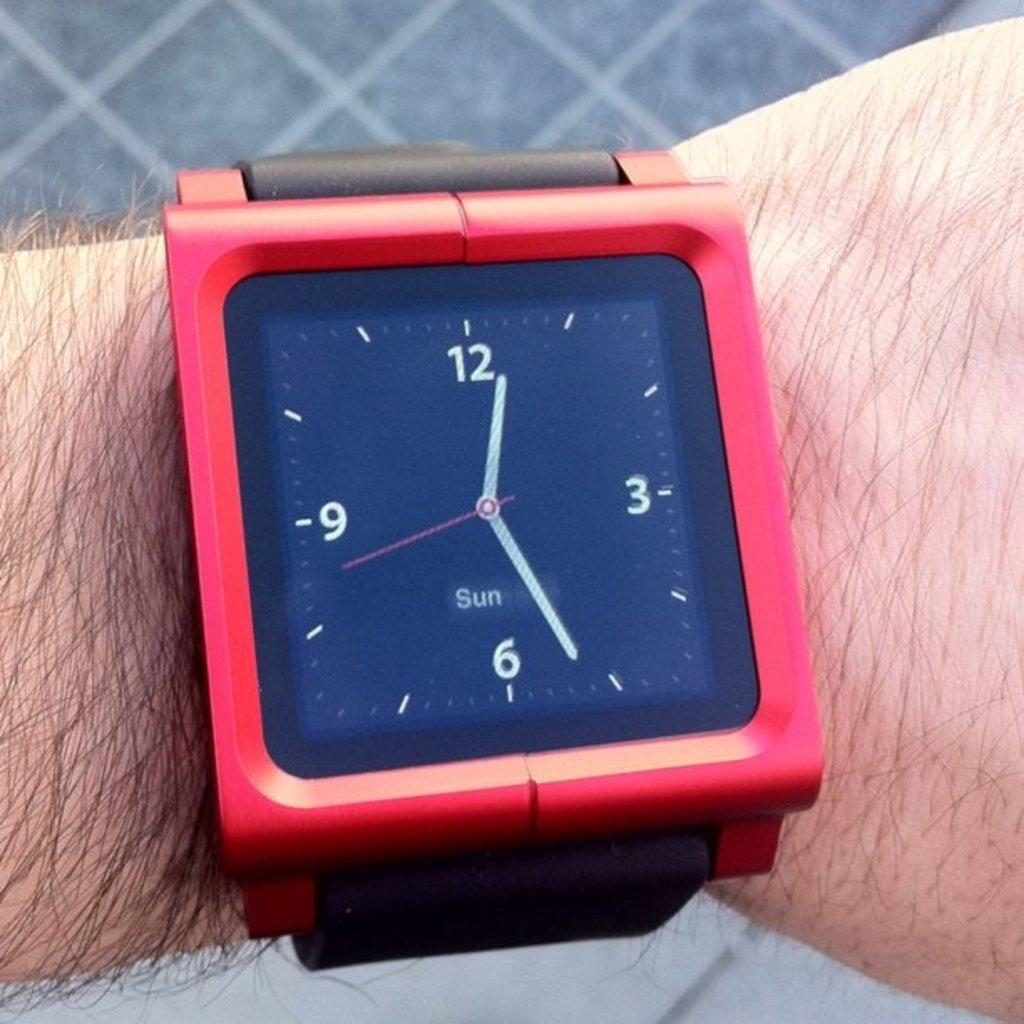<image>
Provide a brief description of the given image. A small display on a wristwatch indicates that the day is Sunday. 